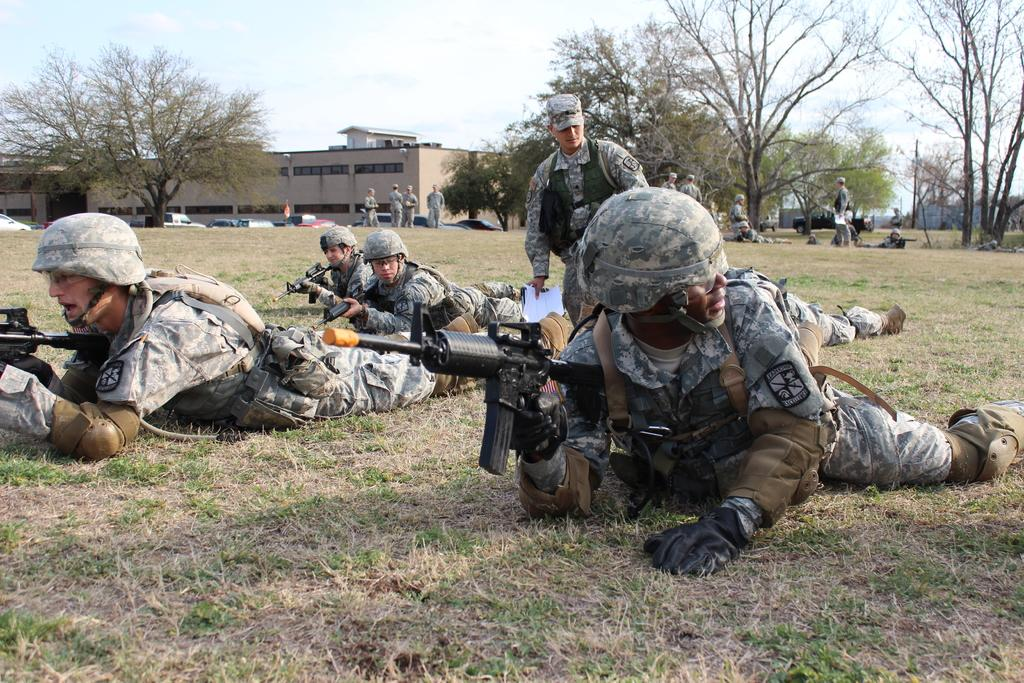What type of people are in the image? There are military men in the image. What are the military men doing in the image? The military men are lying on the ground. What equipment do the military men have in the image? The military men have guns in the image. What can be seen in the background of the image? There is a building and trees in the background of the image. What is visible in the sky in the image? The sky is visible in the image, and clouds are present. Is there a basin visible in the image? There is no basin present in the image. Is the image taken during a rainstorm? The image does not show any signs of a rainstorm, and there is no mention of rain in the provided facts. 